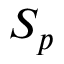<formula> <loc_0><loc_0><loc_500><loc_500>S _ { p }</formula> 